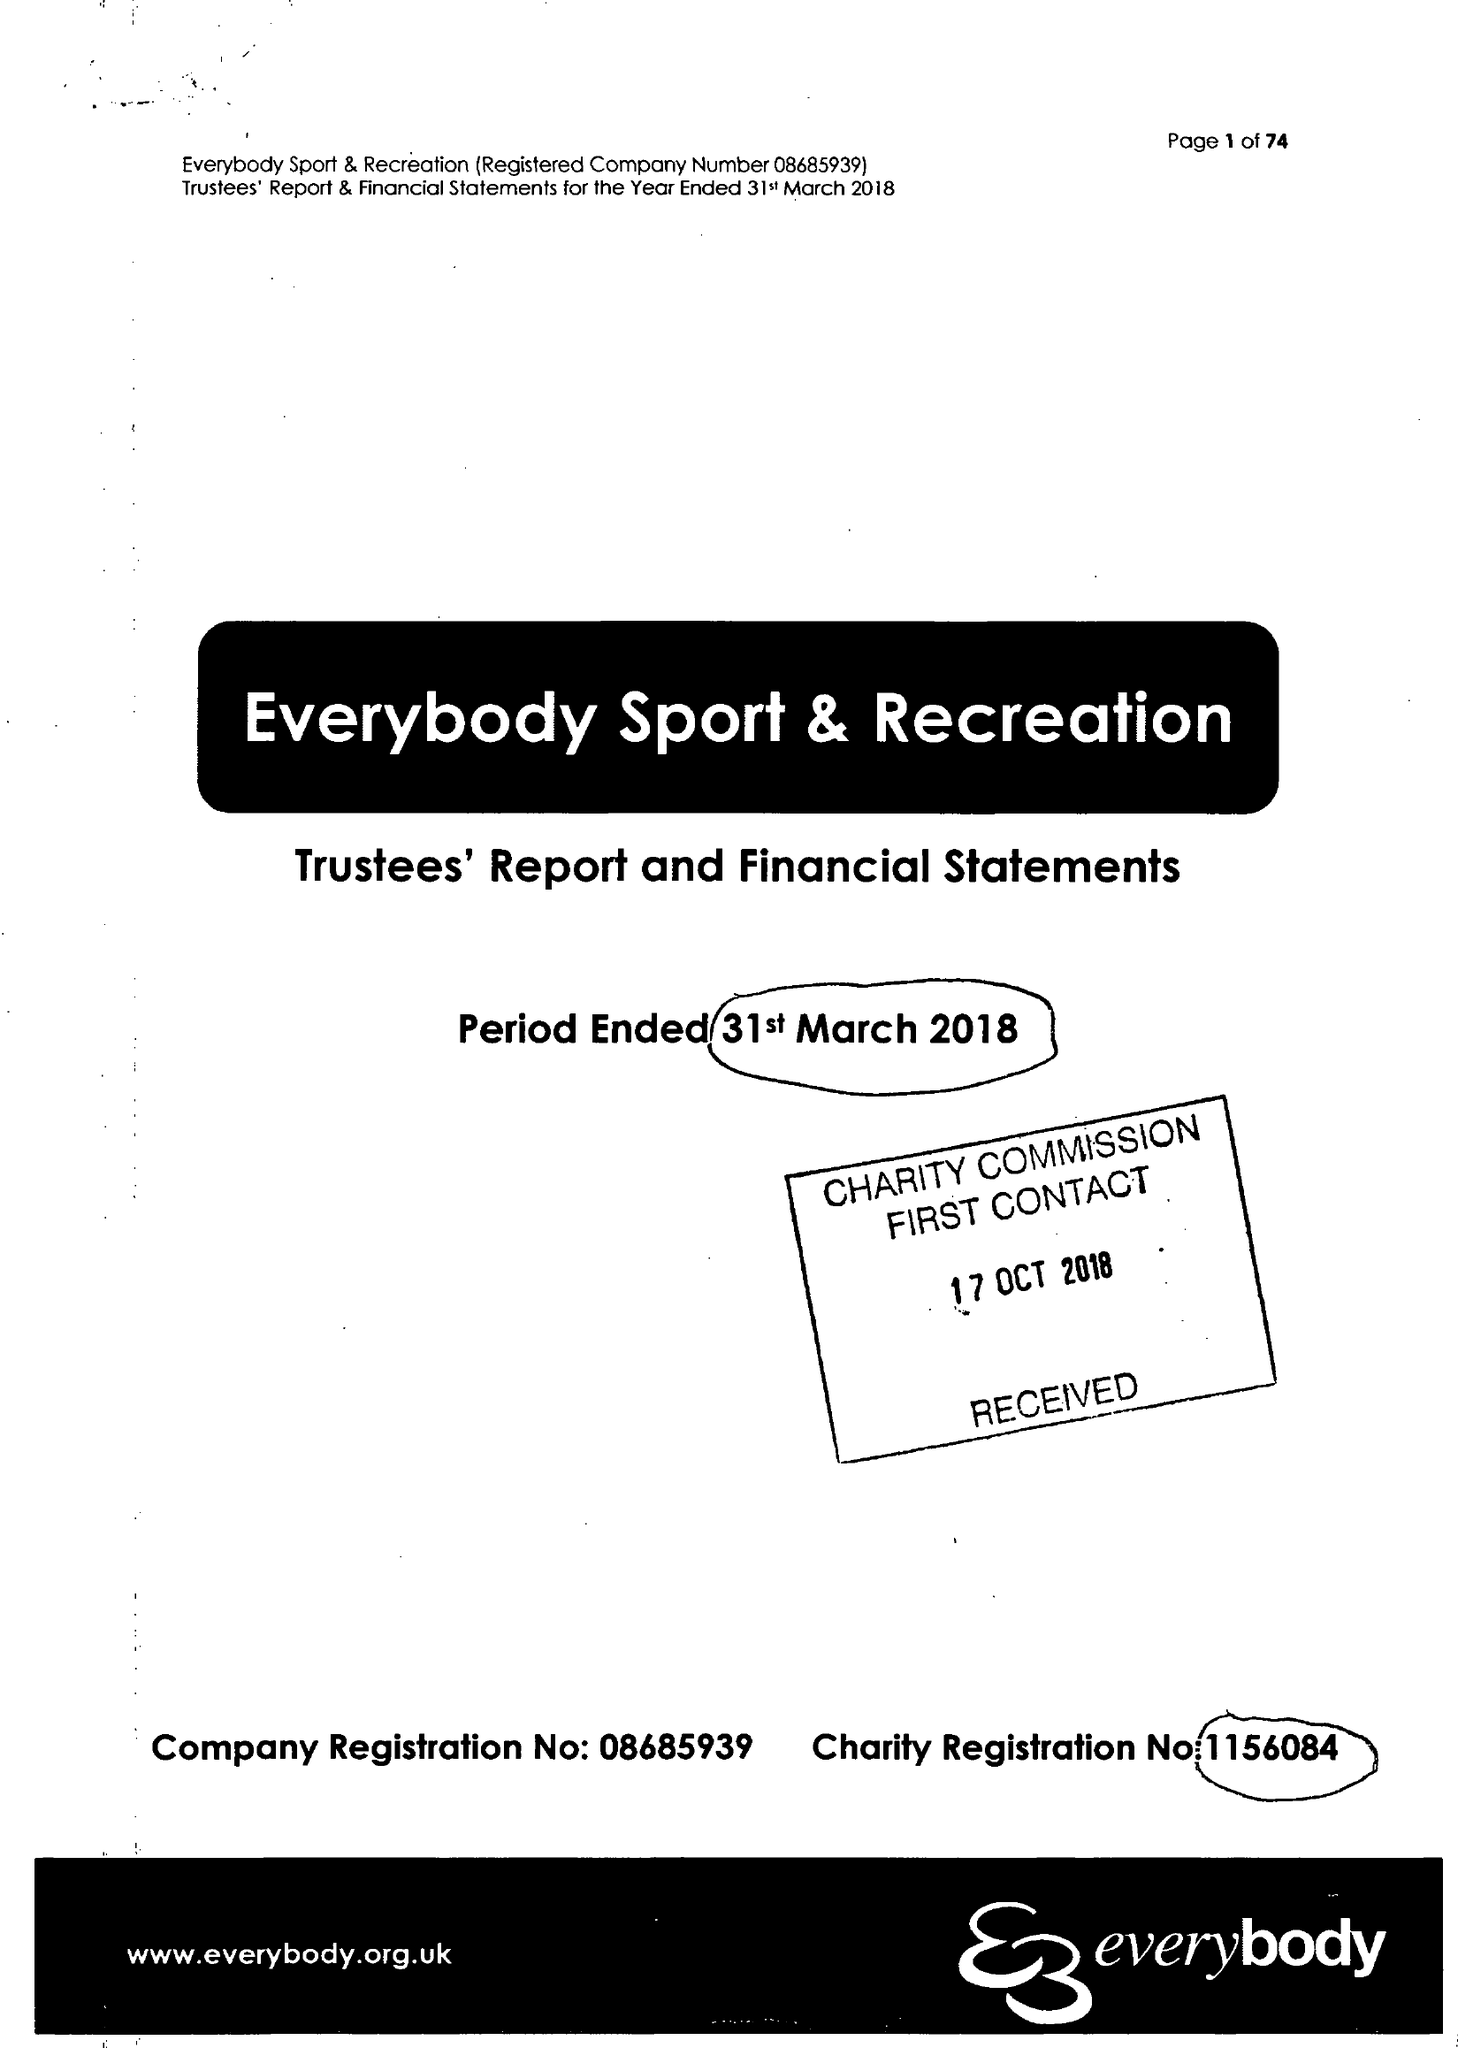What is the value for the income_annually_in_british_pounds?
Answer the question using a single word or phrase. 15446278.00 